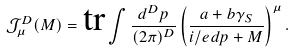Convert formula to latex. <formula><loc_0><loc_0><loc_500><loc_500>\mathcal { J } _ { \mu } ^ { D } ( M ) = \text {tr} \int \frac { d ^ { D } p } { ( 2 \pi ) ^ { D } } \left ( \frac { a + b \gamma _ { S } } { i \slash e d { p } + M } \right ) ^ { \mu } .</formula> 